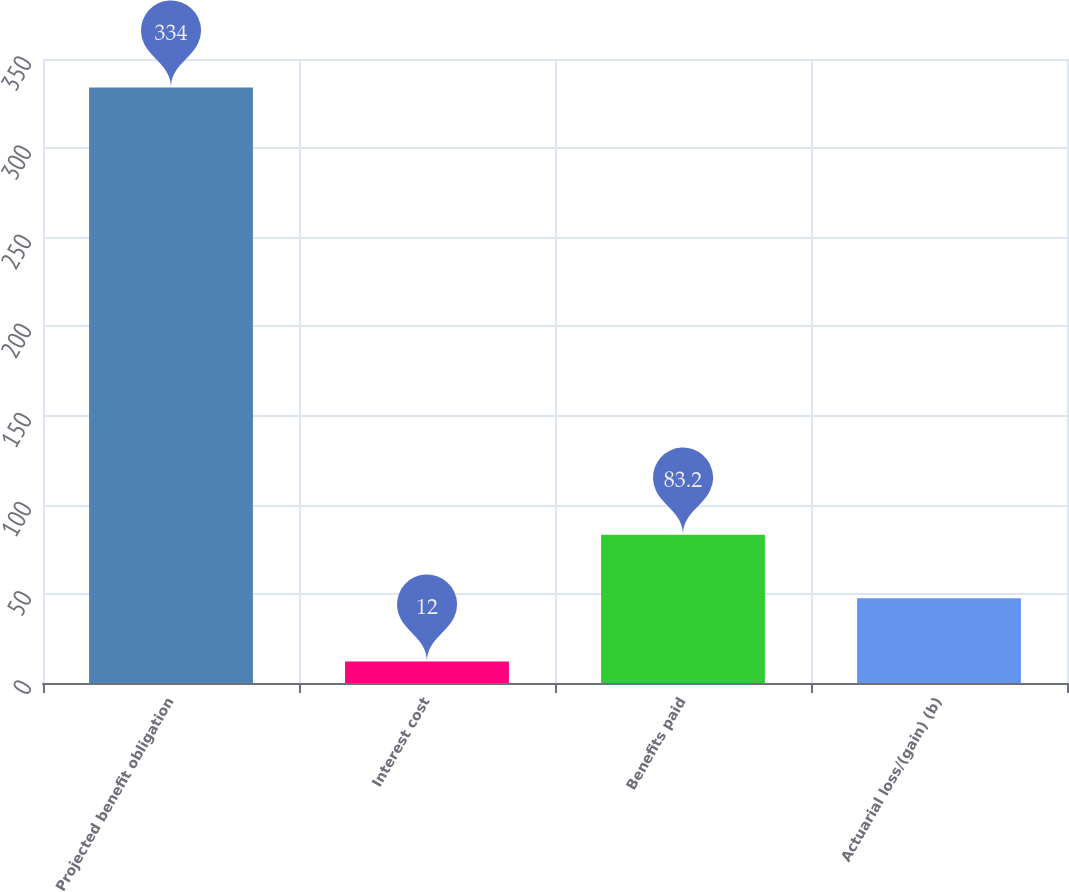Convert chart. <chart><loc_0><loc_0><loc_500><loc_500><bar_chart><fcel>Projected benefit obligation<fcel>Interest cost<fcel>Benefits paid<fcel>Actuarial loss/(gain) (b)<nl><fcel>334<fcel>12<fcel>83.2<fcel>47.6<nl></chart> 